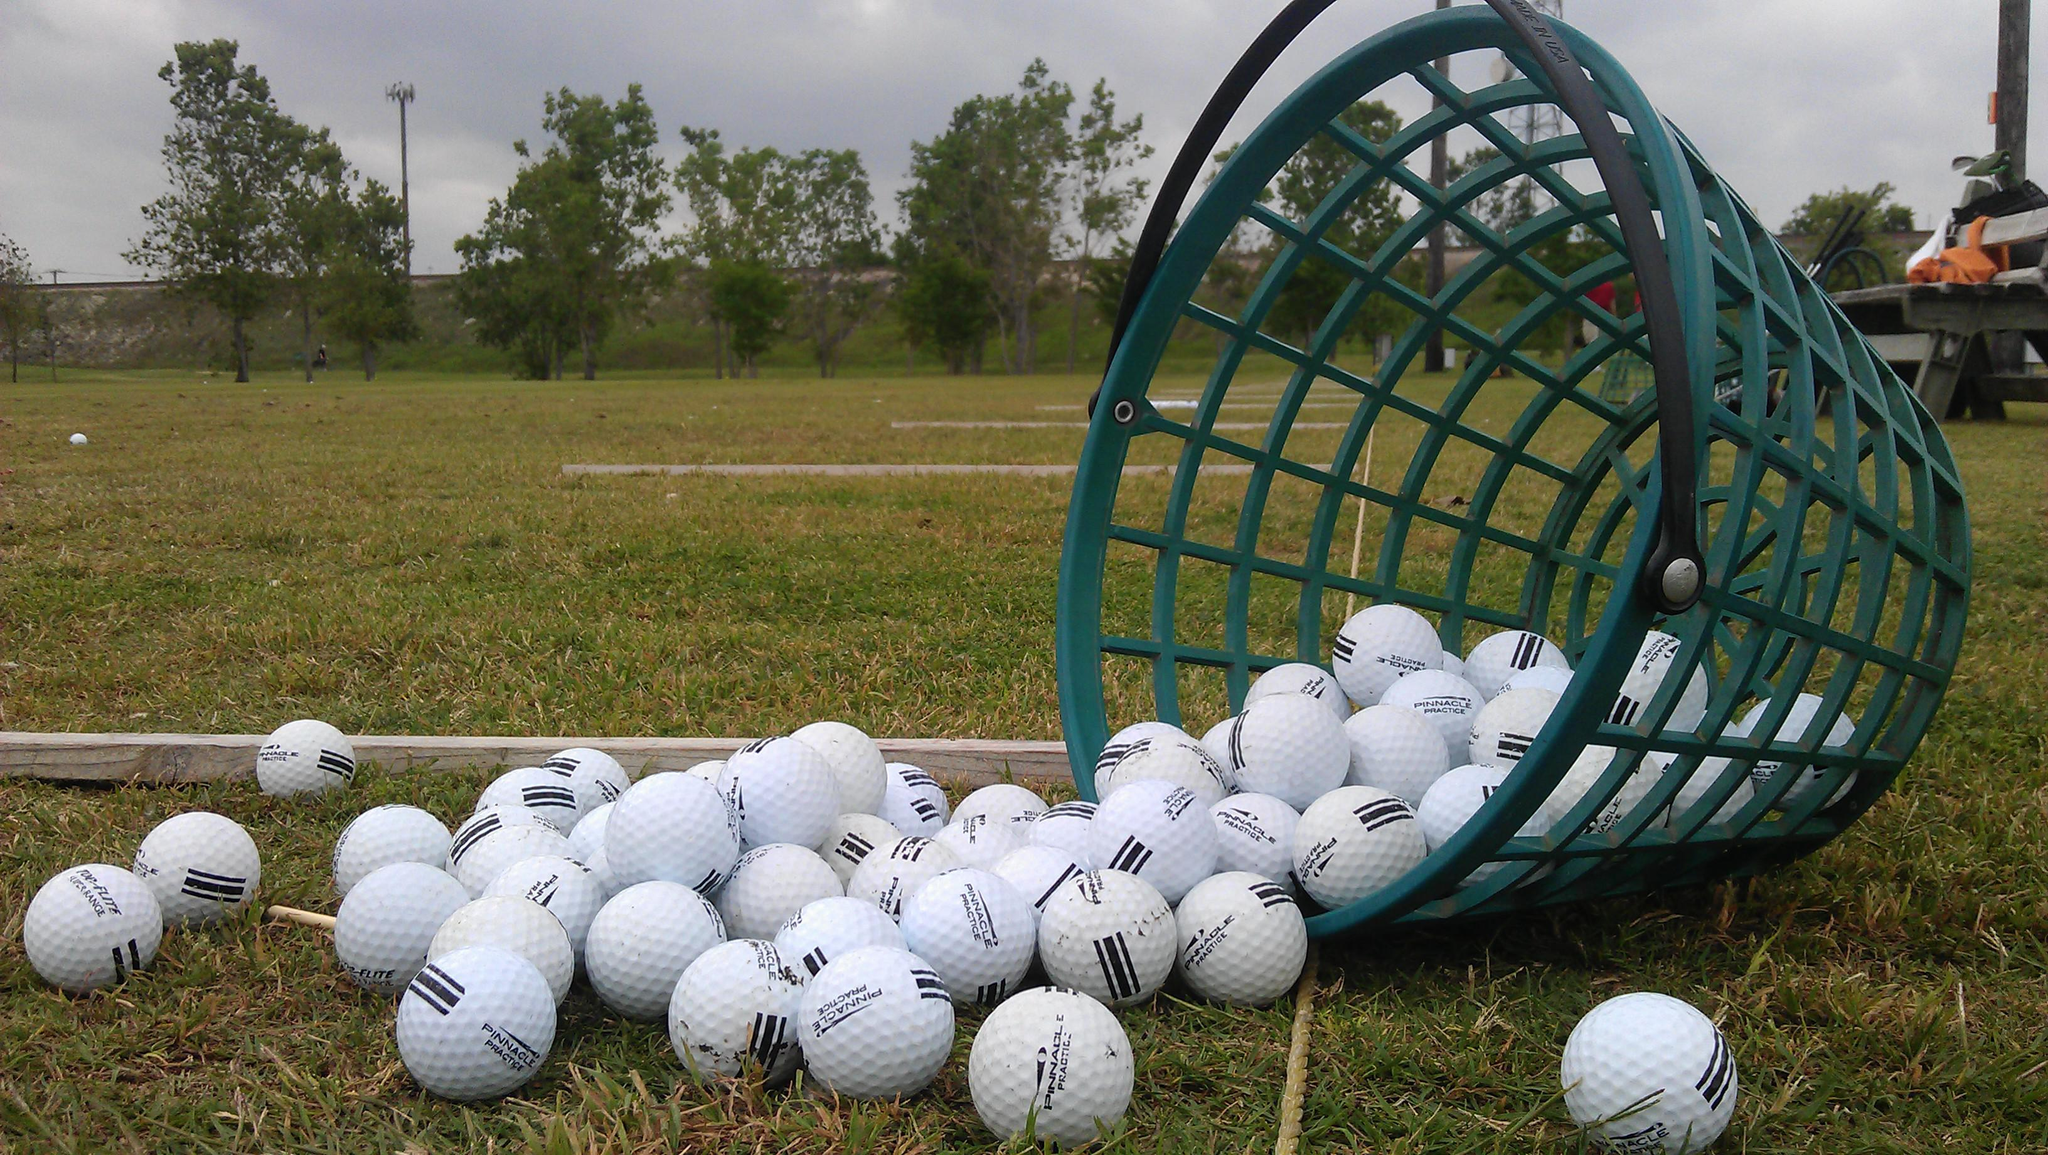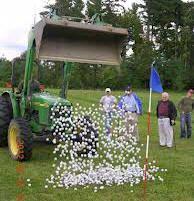The first image is the image on the left, the second image is the image on the right. For the images displayed, is the sentence "Multiple people are standing on green grass in one of the golf-themed images." factually correct? Answer yes or no. Yes. The first image is the image on the left, the second image is the image on the right. For the images shown, is this caption "One image shows gift wrapped golf balls." true? Answer yes or no. No. 